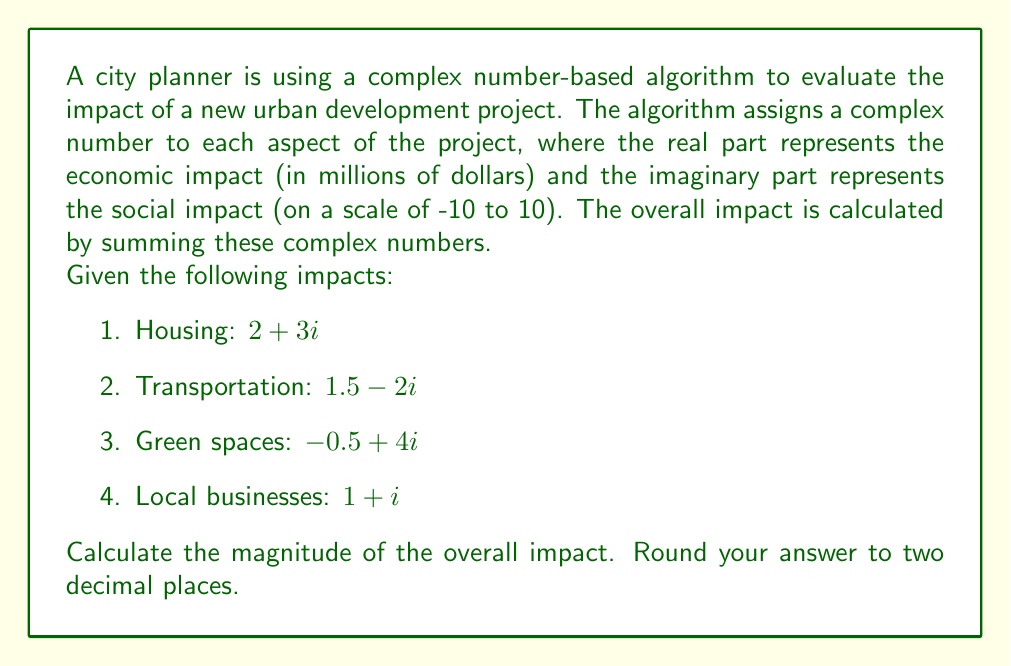Teach me how to tackle this problem. To solve this problem, we'll follow these steps:

1. Sum the complex numbers representing each aspect of the project:
   $$(2 + 3i) + (1.5 - 2i) + (-0.5 + 4i) + (1 + i)$$

2. Combine like terms:
   Real part: $2 + 1.5 + (-0.5) + 1 = 4$
   Imaginary part: $3i + (-2i) + 4i + i = 6i$

3. Express the result as a single complex number:
   $$4 + 6i$$

4. Calculate the magnitude of this complex number using the formula:
   $$|a + bi| = \sqrt{a^2 + b^2}$$
   where $a$ is the real part and $b$ is the imaginary part.

5. Substitute the values:
   $$|4 + 6i| = \sqrt{4^2 + 6^2}$$

6. Compute:
   $$\sqrt{16 + 36} = \sqrt{52} \approx 7.21$$

7. Round to two decimal places: 7.21

The magnitude 7.21 represents the overall impact of the urban development project, combining both economic and social factors.
Answer: 7.21 